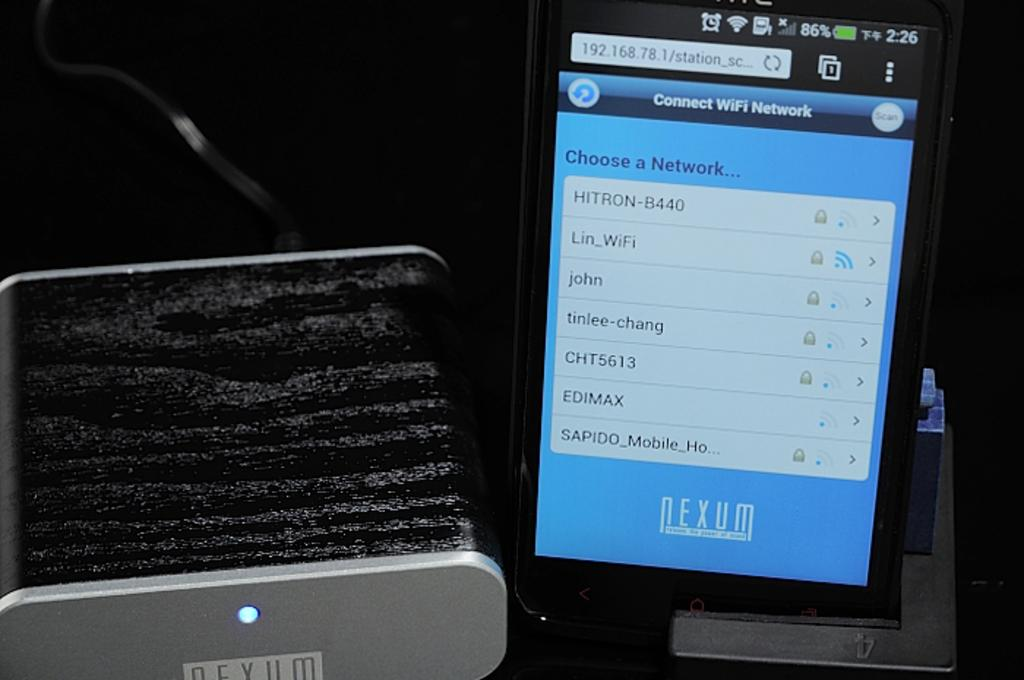<image>
Create a compact narrative representing the image presented. A phone is open to a screen which is titled Connect WIFI Network. 